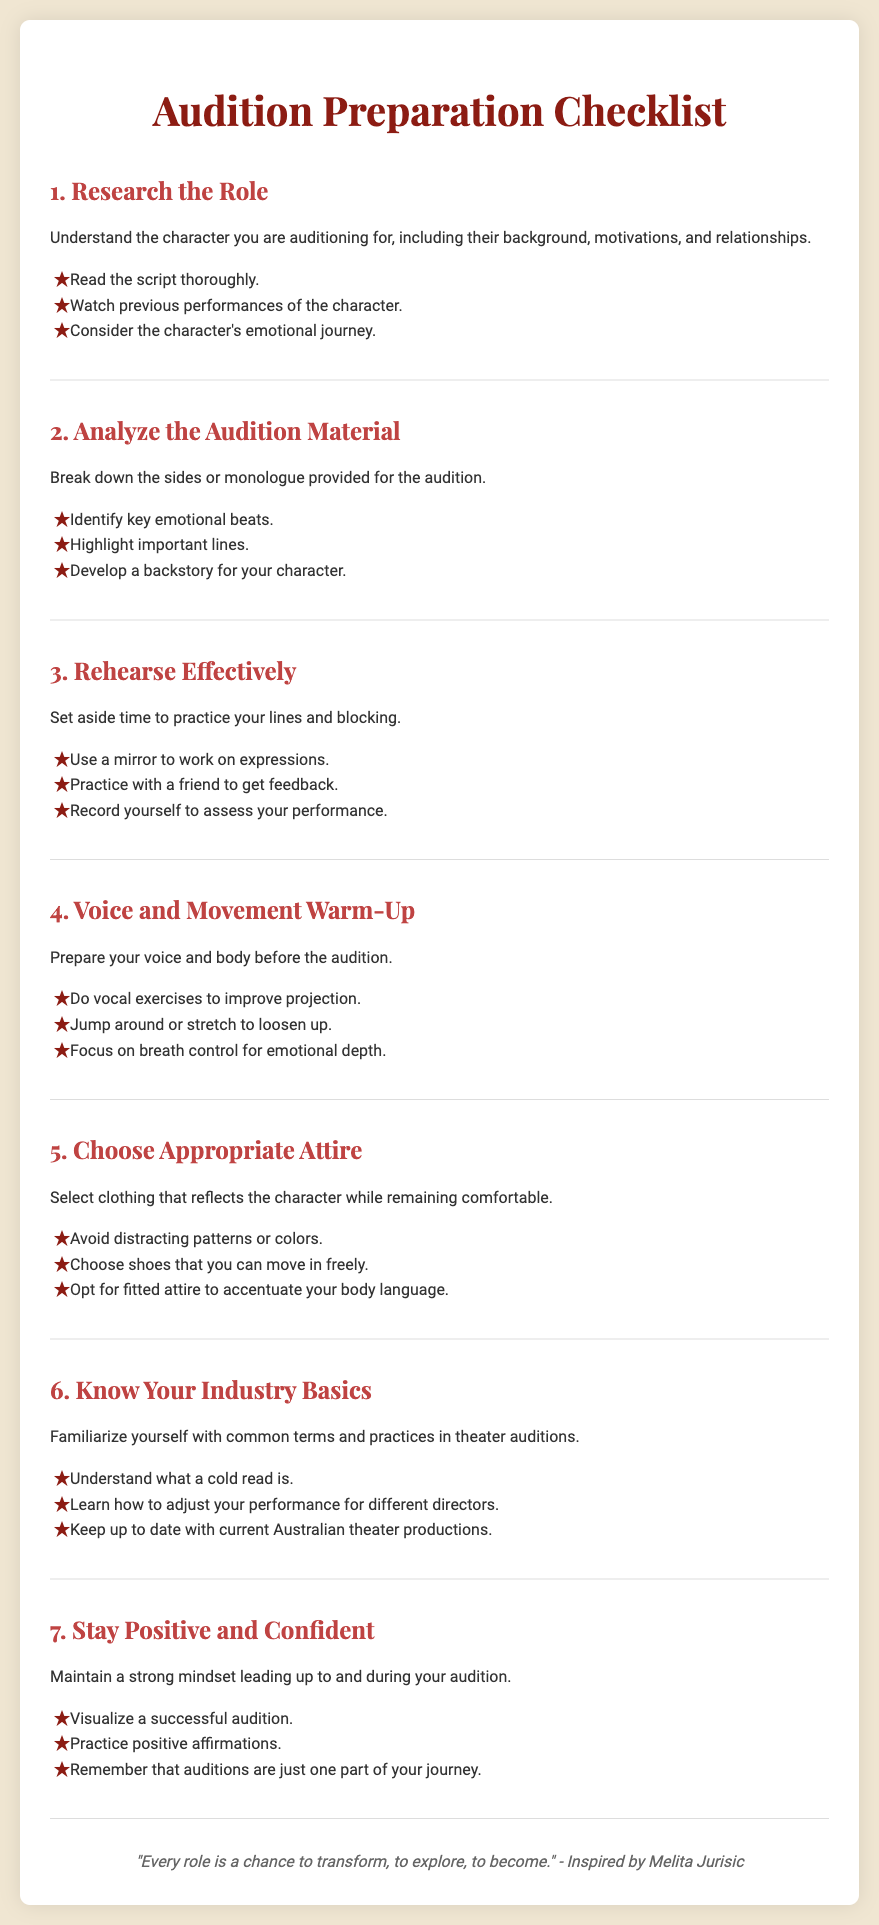What is the title of the document? The title of the document is displayed prominently at the top and is "Audition Preparation Checklist."
Answer: Audition Preparation Checklist How many main sections are there in the document? The document contains 7 main checklist items related to audition preparation.
Answer: 7 What should you do to prepare your voice before an audition? This information is found in the "Voice and Movement Warm-Up" section, which mentions vocal exercises.
Answer: Vocal exercises What is an example of maintaining a positive mindset according to the checklist? The "Stay Positive and Confident" section suggests visualizing a successful audition as an example.
Answer: Visualize a successful audition What type of attire should be avoided according to the checklist? The "Choose Appropriate Attire" section advises avoiding distracting patterns or colors.
Answer: Distracting patterns What is one way to analyze audition material? The checklist suggests identifying key emotional beats as part of analyzing the material.
Answer: Identify key emotional beats What quote is included for inspiration in the document? The document ends with a quote that expresses the transformative power of roles, inspired by Melita Jurisic.
Answer: "Every role is a chance to transform, to explore, to become." 